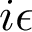<formula> <loc_0><loc_0><loc_500><loc_500>i \epsilon</formula> 